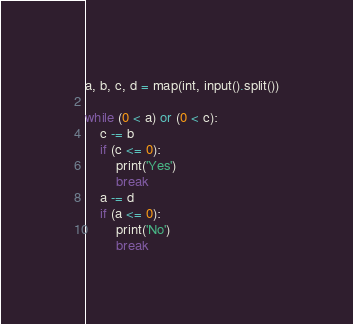<code> <loc_0><loc_0><loc_500><loc_500><_Python_>a, b, c, d = map(int, input().split())

while (0 < a) or (0 < c):
    c -= b
    if (c <= 0):
        print('Yes')
        break
    a -= d
    if (a <= 0):
        print('No')
        break
</code> 